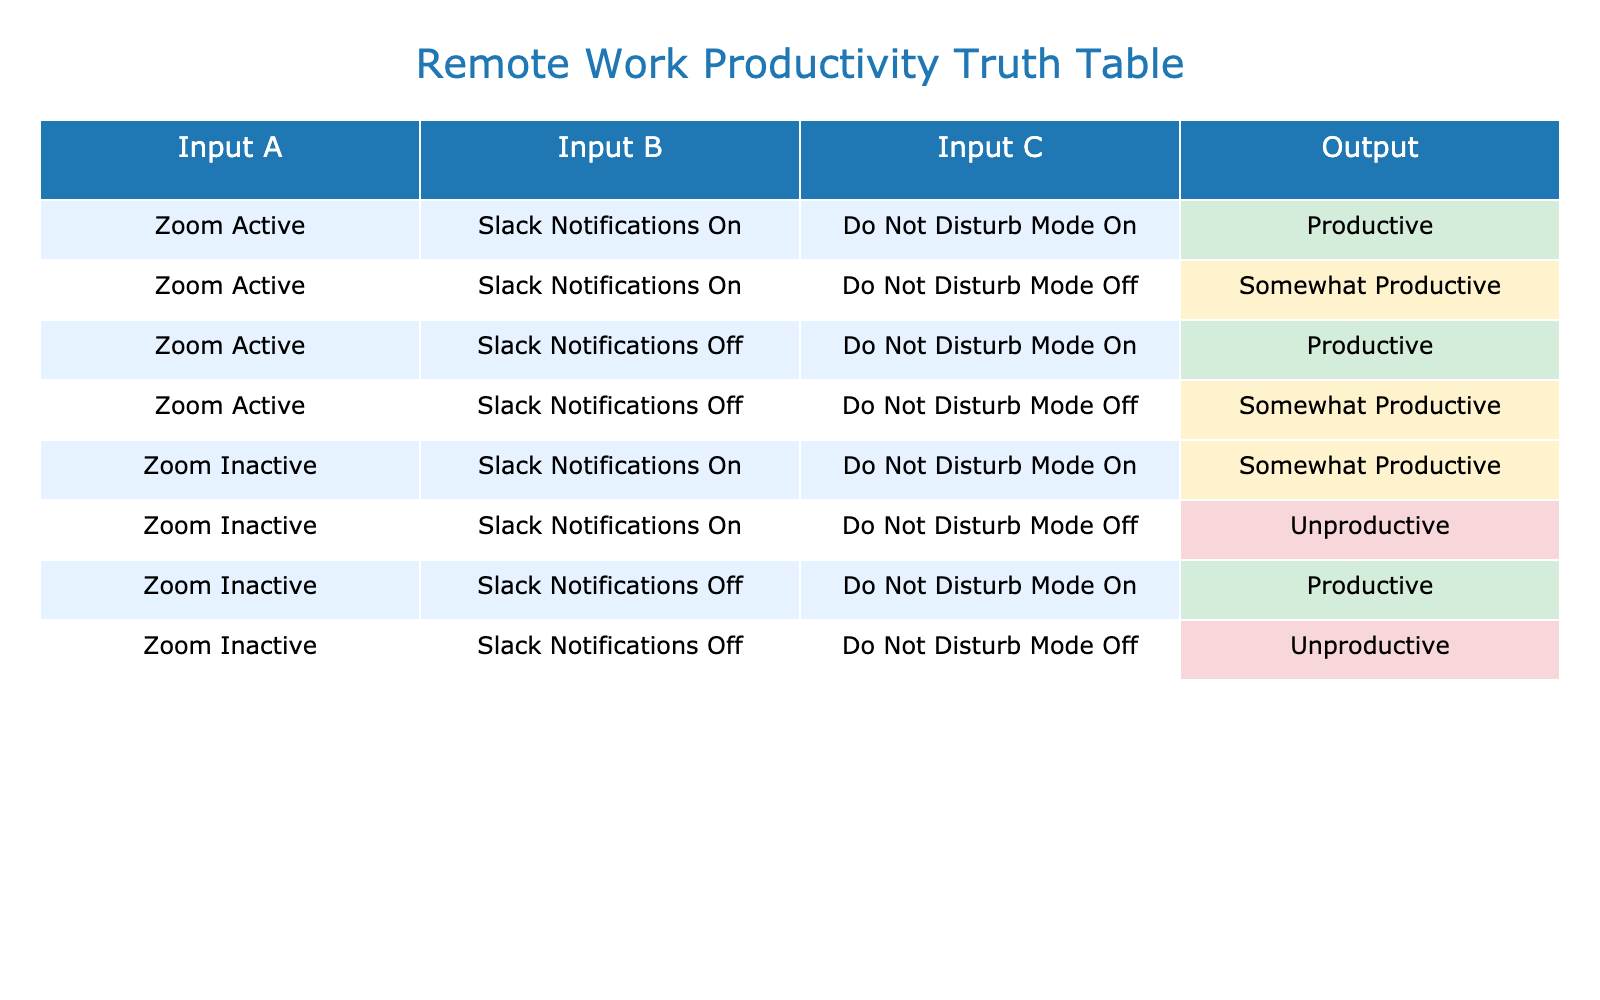What is the output when Zoom is active, Slack notifications are on, and Do Not Disturb mode is on? In the table, when Zoom is active, Slack notifications are on, and Do Not Disturb mode is on, the corresponding output is "Productive."
Answer: Productive How many scenarios lead to being unproductive? There are two scenarios in the table that result in "Unproductive," specifically when Zoom is inactive with Slack notifications on and Do Not Disturb mode off, and when Zoom is inactive with Slack notifications off and Do Not Disturb mode off.
Answer: 2 Is it true that having Do Not Disturb mode on guarantees productivity? Reviewing the rows in the table, there are instances where Do Not Disturb mode is on, but if Zoom is inactive or Slack notifications are on, it does not guarantee productivity, as some cases yield "Somewhat Productive." Therefore, the statement is false.
Answer: No What is the output if Zoom is inactive and Slack notifications are off with Do Not Disturb mode on? Looking at the table, the specific scenario of Zoom inactive, Slack notifications off, and Do Not Disturb mode on results in "Productive."
Answer: Productive When Zoom is active and Do Not Disturb mode is off, how many outputs indicate being somewhat productive? In the table, when Zoom is active and Do Not Disturb mode is off, there are two instances: one with Slack notifications on and another with Slack notifications off, both resulting in "Somewhat Productive." So, there are two outputs.
Answer: 2 What is the most productive scenario? The table shows multiple "Productive" outputs but the scenario with Zoom active, Slack notifications off, and Do Not Disturb mode on is noted as "Productive," which is one of the most favorable combinations.
Answer: Zoom Active, Slack Notifications Off, Do Not Disturb Mode On Is it possible to be productive with Zoom inactive? By examining the table, there is a case where Zoom is inactive, Slack notifications are off, and Do Not Disturb mode is on that leads to a "Productive" outcome. Thus, it is possible under specific conditions to be productive even with Zoom inactive.
Answer: Yes What is the output if Zoom is inactive and Slack notifications are on, regardless of Do Not Disturb mode? The table reveals that when Zoom is inactive and Slack notifications are on, the output is "Somewhat Productive" when Do Not Disturb mode is on, and "Unproductive" when it is off. Therefore, the overall output can vary based on Do Not Disturb settings, with "Unproductive" being one of the results.
Answer: Varies (Somewhat Productive or Unproductive) 